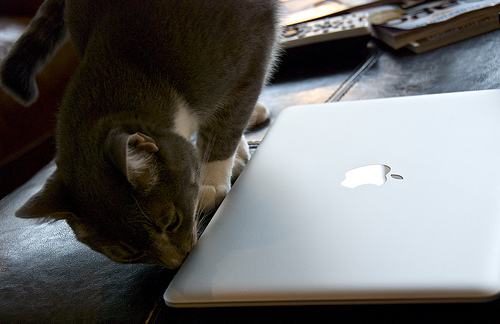What time of day does it look like in the image? The lighting in the image seems natural and not overly bright, suggesting it could be daytime with indirect sunlight filtering into the room, possibly morning or afternoon. 